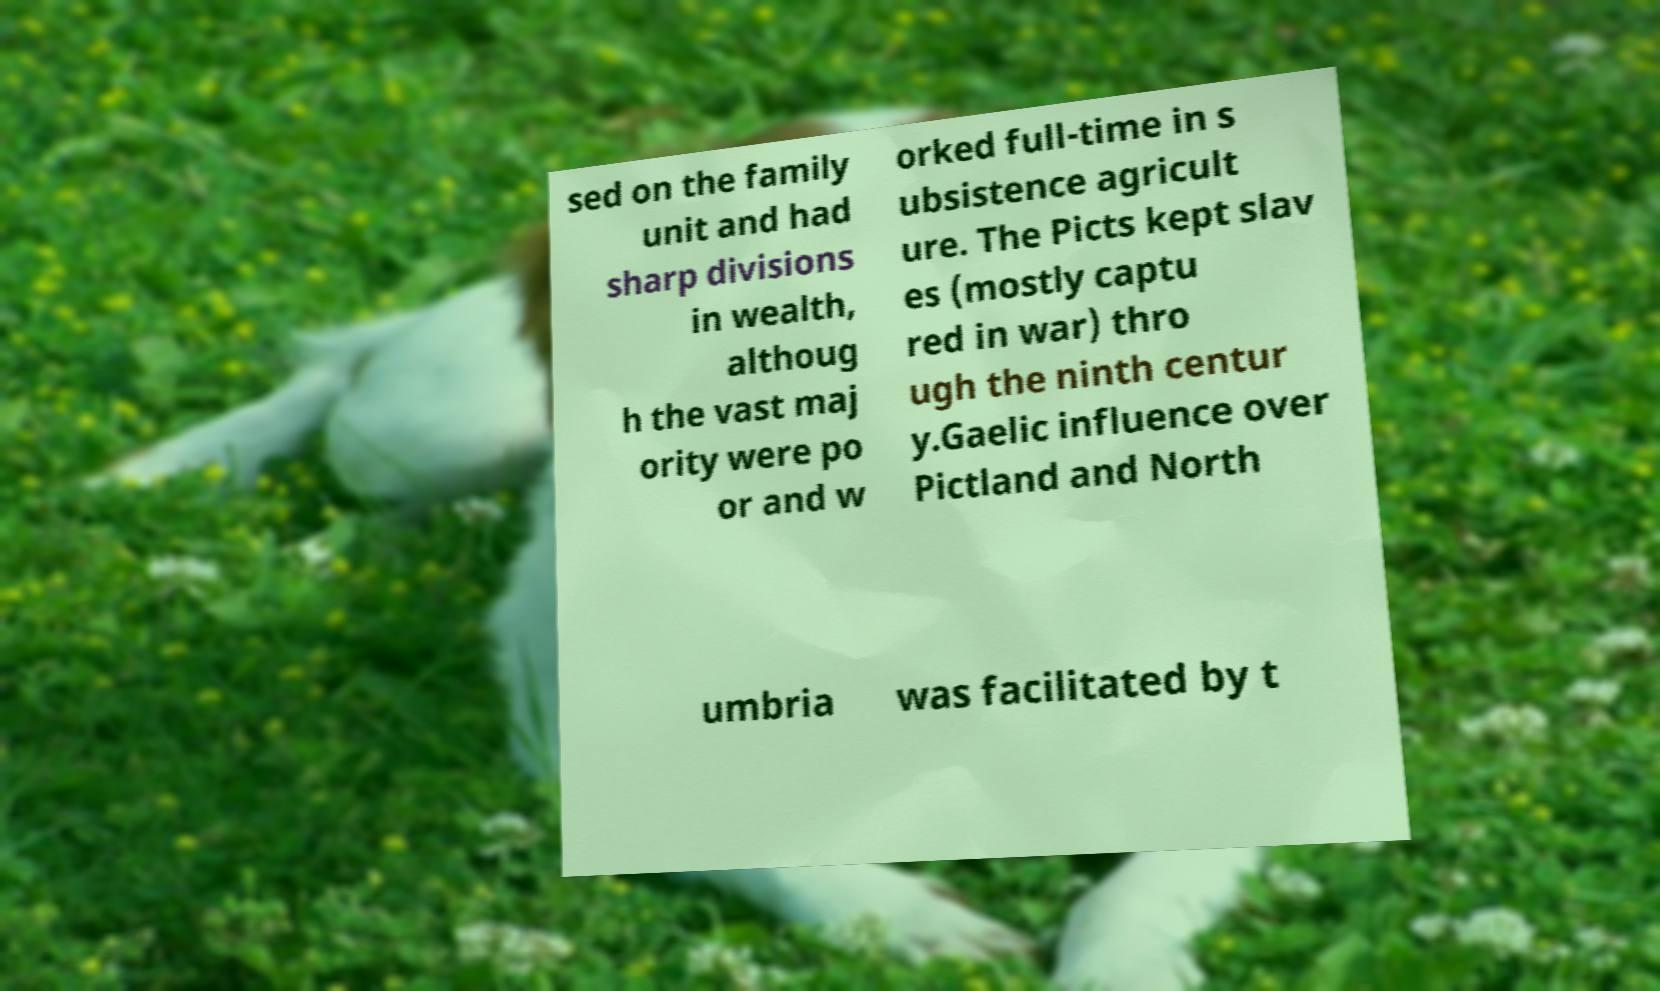For documentation purposes, I need the text within this image transcribed. Could you provide that? sed on the family unit and had sharp divisions in wealth, althoug h the vast maj ority were po or and w orked full-time in s ubsistence agricult ure. The Picts kept slav es (mostly captu red in war) thro ugh the ninth centur y.Gaelic influence over Pictland and North umbria was facilitated by t 